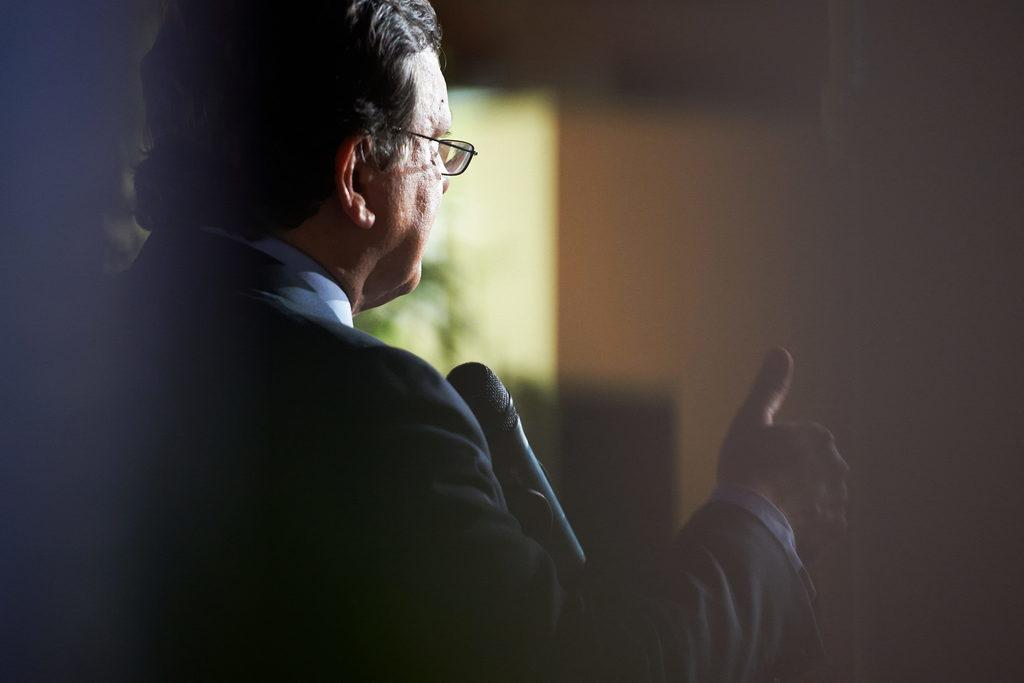What is the main subject of the image? There is a man in the image. What object is present in the image along with the man? There is a microphone in the image. What type of wool is the man using to play a trade game in the image? There is no wool, play, or trade game present in the image. 